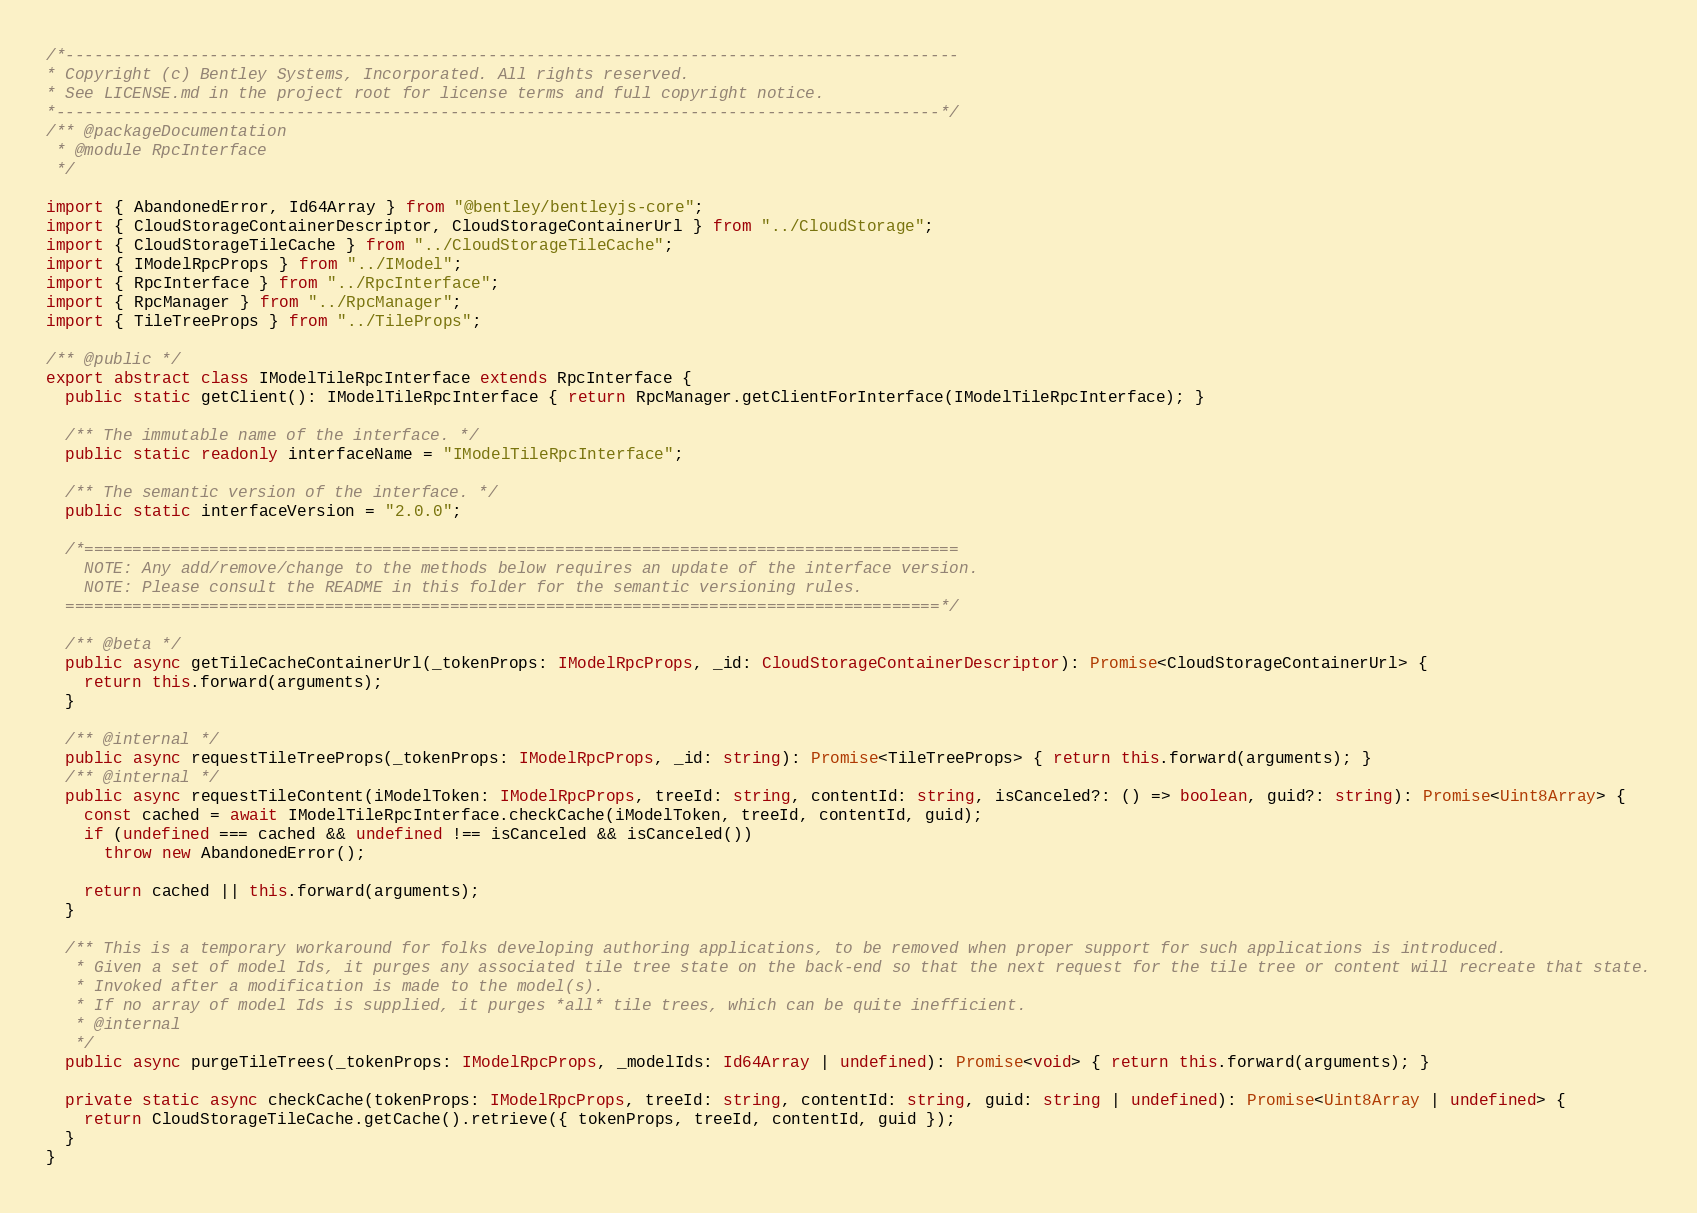<code> <loc_0><loc_0><loc_500><loc_500><_TypeScript_>/*---------------------------------------------------------------------------------------------
* Copyright (c) Bentley Systems, Incorporated. All rights reserved.
* See LICENSE.md in the project root for license terms and full copyright notice.
*--------------------------------------------------------------------------------------------*/
/** @packageDocumentation
 * @module RpcInterface
 */

import { AbandonedError, Id64Array } from "@bentley/bentleyjs-core";
import { CloudStorageContainerDescriptor, CloudStorageContainerUrl } from "../CloudStorage";
import { CloudStorageTileCache } from "../CloudStorageTileCache";
import { IModelRpcProps } from "../IModel";
import { RpcInterface } from "../RpcInterface";
import { RpcManager } from "../RpcManager";
import { TileTreeProps } from "../TileProps";

/** @public */
export abstract class IModelTileRpcInterface extends RpcInterface {
  public static getClient(): IModelTileRpcInterface { return RpcManager.getClientForInterface(IModelTileRpcInterface); }

  /** The immutable name of the interface. */
  public static readonly interfaceName = "IModelTileRpcInterface";

  /** The semantic version of the interface. */
  public static interfaceVersion = "2.0.0";

  /*===========================================================================================
    NOTE: Any add/remove/change to the methods below requires an update of the interface version.
    NOTE: Please consult the README in this folder for the semantic versioning rules.
  ===========================================================================================*/

  /** @beta */
  public async getTileCacheContainerUrl(_tokenProps: IModelRpcProps, _id: CloudStorageContainerDescriptor): Promise<CloudStorageContainerUrl> {
    return this.forward(arguments);
  }

  /** @internal */
  public async requestTileTreeProps(_tokenProps: IModelRpcProps, _id: string): Promise<TileTreeProps> { return this.forward(arguments); }
  /** @internal */
  public async requestTileContent(iModelToken: IModelRpcProps, treeId: string, contentId: string, isCanceled?: () => boolean, guid?: string): Promise<Uint8Array> {
    const cached = await IModelTileRpcInterface.checkCache(iModelToken, treeId, contentId, guid);
    if (undefined === cached && undefined !== isCanceled && isCanceled())
      throw new AbandonedError();

    return cached || this.forward(arguments);
  }

  /** This is a temporary workaround for folks developing authoring applications, to be removed when proper support for such applications is introduced.
   * Given a set of model Ids, it purges any associated tile tree state on the back-end so that the next request for the tile tree or content will recreate that state.
   * Invoked after a modification is made to the model(s).
   * If no array of model Ids is supplied, it purges *all* tile trees, which can be quite inefficient.
   * @internal
   */
  public async purgeTileTrees(_tokenProps: IModelRpcProps, _modelIds: Id64Array | undefined): Promise<void> { return this.forward(arguments); }

  private static async checkCache(tokenProps: IModelRpcProps, treeId: string, contentId: string, guid: string | undefined): Promise<Uint8Array | undefined> {
    return CloudStorageTileCache.getCache().retrieve({ tokenProps, treeId, contentId, guid });
  }
}
</code> 